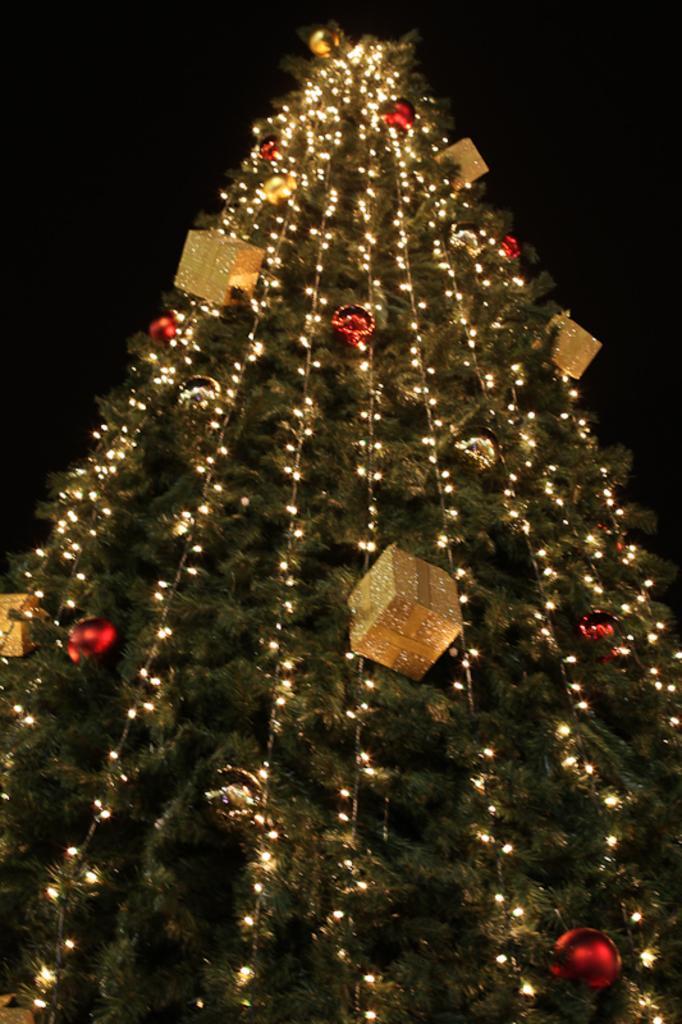Could you give a brief overview of what you see in this image? Here in this picture we can see a Christmas tree, which is fully decorated with lights and gift boxes on it over there. 